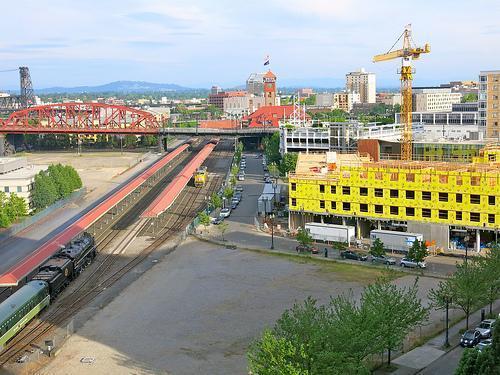How many trains?
Give a very brief answer. 1. 